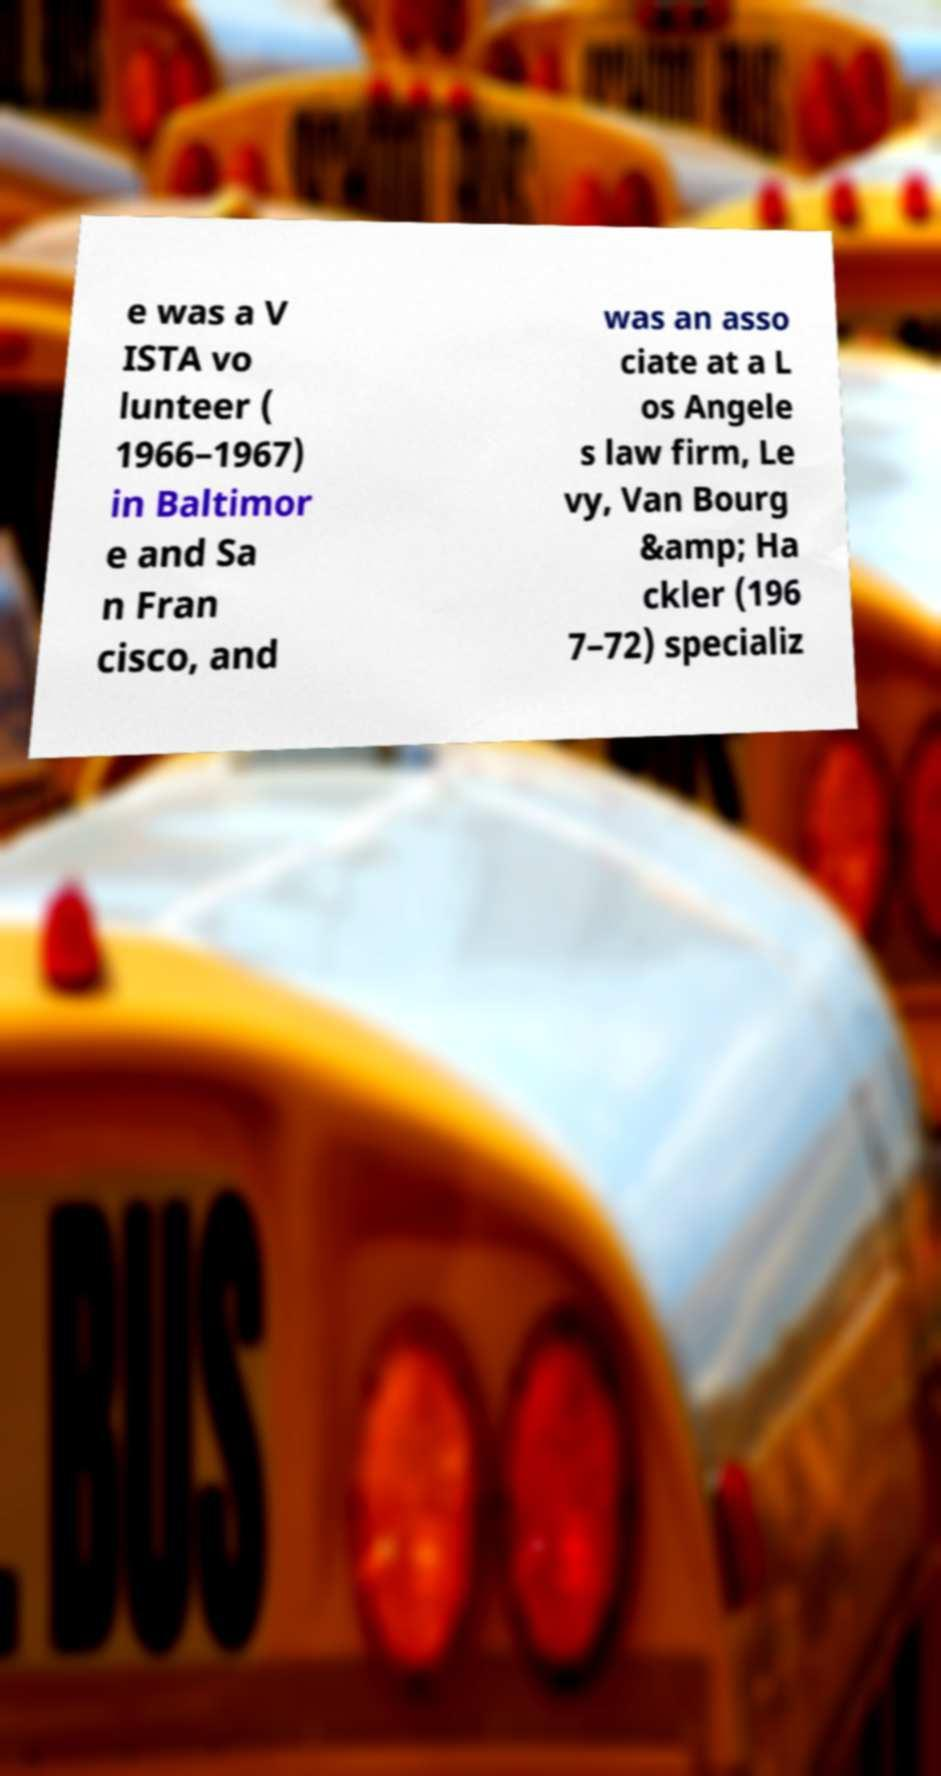For documentation purposes, I need the text within this image transcribed. Could you provide that? e was a V ISTA vo lunteer ( 1966–1967) in Baltimor e and Sa n Fran cisco, and was an asso ciate at a L os Angele s law firm, Le vy, Van Bourg &amp; Ha ckler (196 7–72) specializ 